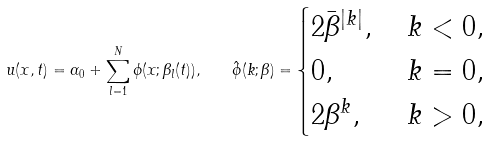Convert formula to latex. <formula><loc_0><loc_0><loc_500><loc_500>u ( x , t ) = \alpha _ { 0 } + \sum _ { l = 1 } ^ { N } \phi ( x ; \beta _ { l } ( t ) ) , \quad \hat { \phi } ( k ; \beta ) = \begin{cases} 2 \bar { \beta } ^ { | k | } , & \, k < 0 , \\ 0 , & \, k = 0 , \\ 2 \beta ^ { k } , & \, k > 0 , \end{cases}</formula> 